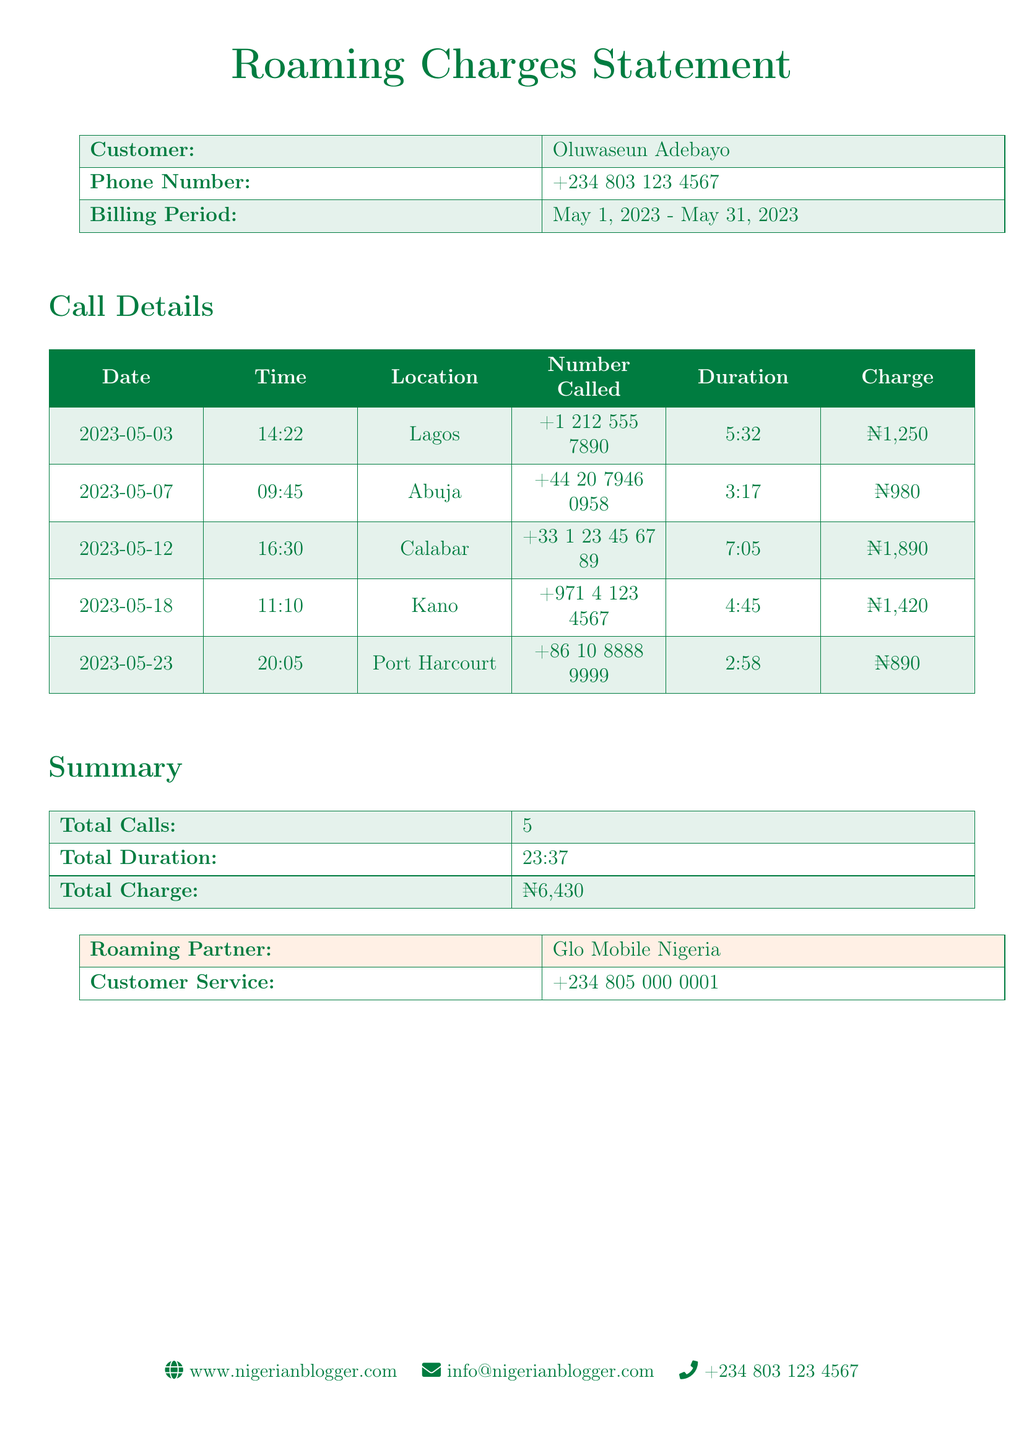what is the name of the customer? The customer's name is stated at the top of the document in the customer information section.
Answer: Oluwaseun Adebayo what is the billing period? The billing period shows the start and end dates for the roaming charges documented.
Answer: May 1, 2023 - May 31, 2023 how many total calls were made? The total calls made are summarized in the document under the summary section.
Answer: 5 what was the charge for the call made from Calabar? The charge for the specific call is indicated in the call details table.
Answer: ₦1,890 what is the total duration of all calls? The total duration is listed in the summary section of the document, which aggregates the duration from all calls made.
Answer: 23:37 which location had the highest charge for a call? The location and charge details are laid out in the call details section, and judging by the charges, the highest can be inferred.
Answer: Calabar what is the phone number for customer service? The customer service phone number is provided in the last table of the document.
Answer: +234 805 000 0001 what is the date of the call made to the number +1 212 555 7890? The date corresponds to the entry in the call details concerning that particular number.
Answer: 2023-05-03 what is the total charge incurred during the billing period? The total charge reflects the summation of all charges on the calls made during the specified period.
Answer: ₦6,430 